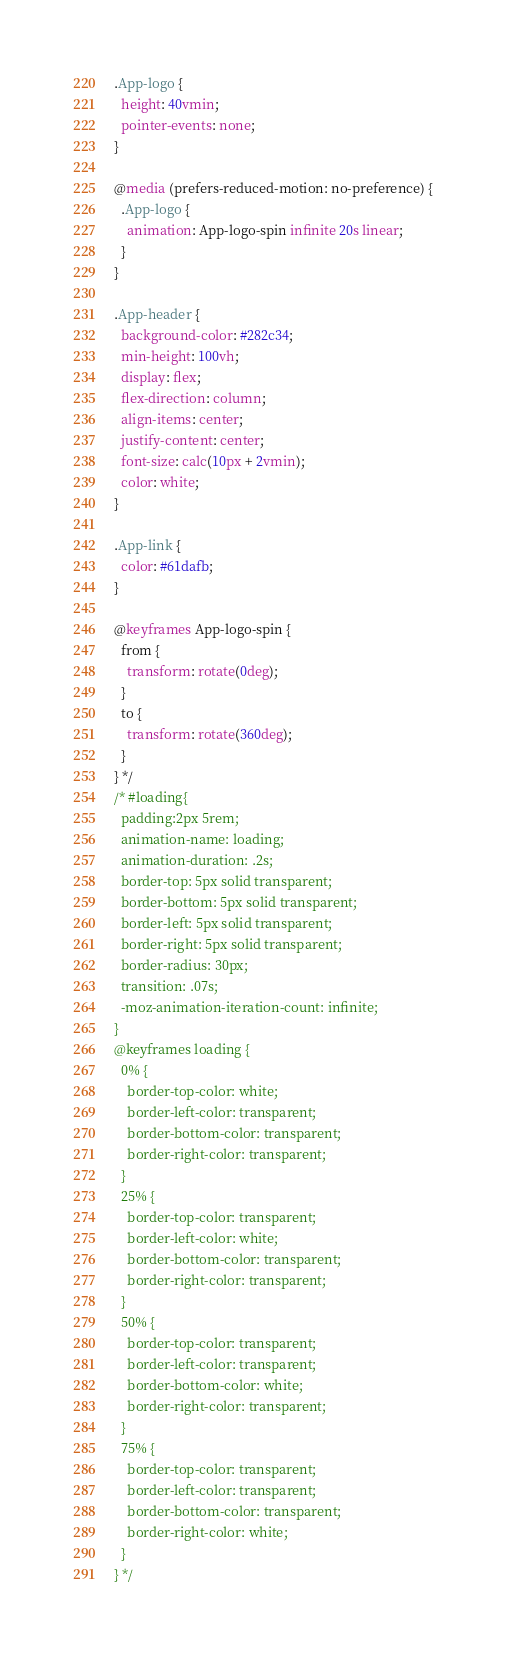Convert code to text. <code><loc_0><loc_0><loc_500><loc_500><_CSS_>.App-logo {
  height: 40vmin;
  pointer-events: none;
}

@media (prefers-reduced-motion: no-preference) {
  .App-logo {
    animation: App-logo-spin infinite 20s linear;
  }
}

.App-header {
  background-color: #282c34;
  min-height: 100vh;
  display: flex;
  flex-direction: column;
  align-items: center;
  justify-content: center;
  font-size: calc(10px + 2vmin);
  color: white;
}

.App-link {
  color: #61dafb;
}

@keyframes App-logo-spin {
  from {
    transform: rotate(0deg);
  }
  to {
    transform: rotate(360deg);
  }
} */
/* #loading{
  padding:2px 5rem;
  animation-name: loading;
  animation-duration: .2s;
  border-top: 5px solid transparent;
  border-bottom: 5px solid transparent;
  border-left: 5px solid transparent;
  border-right: 5px solid transparent;
  border-radius: 30px;
  transition: .07s;
  -moz-animation-iteration-count: infinite;
}
@keyframes loading {
  0% {
    border-top-color: white;
    border-left-color: transparent;
    border-bottom-color: transparent;
    border-right-color: transparent;
  }
  25% {
    border-top-color: transparent;
    border-left-color: white;
    border-bottom-color: transparent;
    border-right-color: transparent;
  }
  50% {
    border-top-color: transparent;
    border-left-color: transparent;
    border-bottom-color: white;
    border-right-color: transparent;
  }
  75% {
    border-top-color: transparent;
    border-left-color: transparent;
    border-bottom-color: transparent;
    border-right-color: white;
  }
} */
</code> 